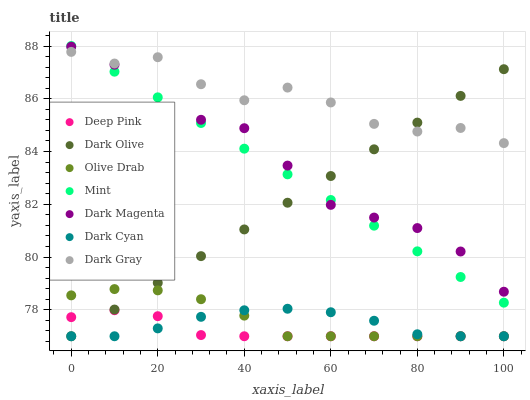Does Deep Pink have the minimum area under the curve?
Answer yes or no. Yes. Does Dark Gray have the maximum area under the curve?
Answer yes or no. Yes. Does Dark Magenta have the minimum area under the curve?
Answer yes or no. No. Does Dark Magenta have the maximum area under the curve?
Answer yes or no. No. Is Dark Olive the smoothest?
Answer yes or no. Yes. Is Dark Gray the roughest?
Answer yes or no. Yes. Is Dark Magenta the smoothest?
Answer yes or no. No. Is Dark Magenta the roughest?
Answer yes or no. No. Does Deep Pink have the lowest value?
Answer yes or no. Yes. Does Dark Magenta have the lowest value?
Answer yes or no. No. Does Mint have the highest value?
Answer yes or no. Yes. Does Dark Magenta have the highest value?
Answer yes or no. No. Is Dark Cyan less than Dark Magenta?
Answer yes or no. Yes. Is Dark Gray greater than Deep Pink?
Answer yes or no. Yes. Does Dark Olive intersect Dark Magenta?
Answer yes or no. Yes. Is Dark Olive less than Dark Magenta?
Answer yes or no. No. Is Dark Olive greater than Dark Magenta?
Answer yes or no. No. Does Dark Cyan intersect Dark Magenta?
Answer yes or no. No. 